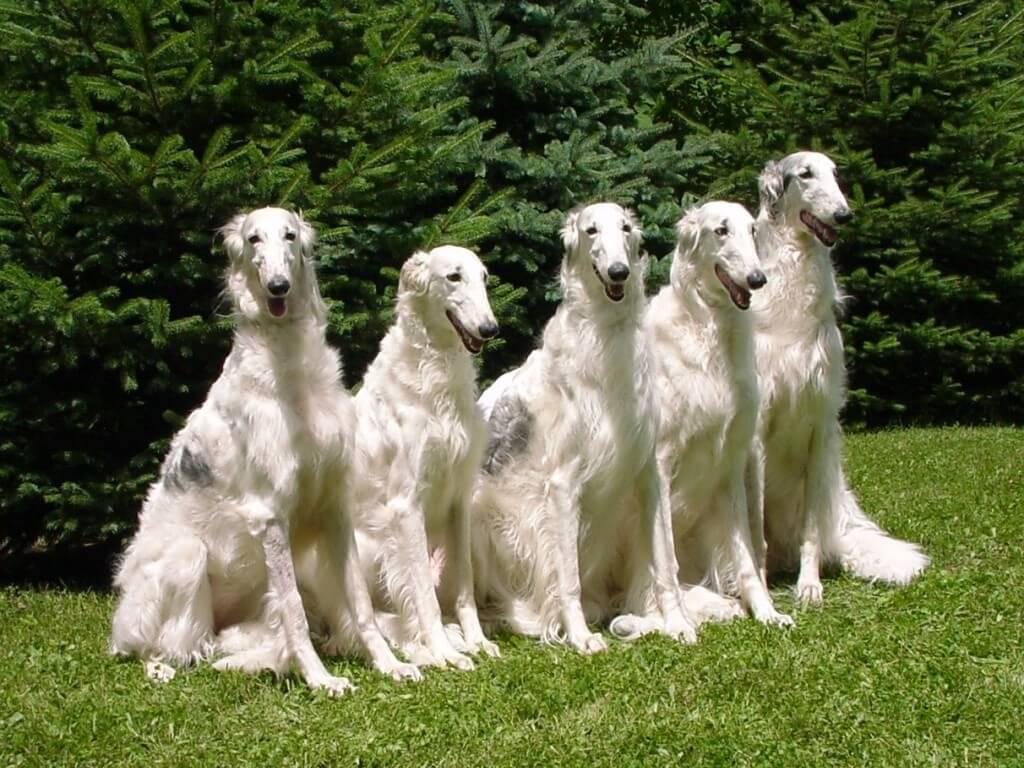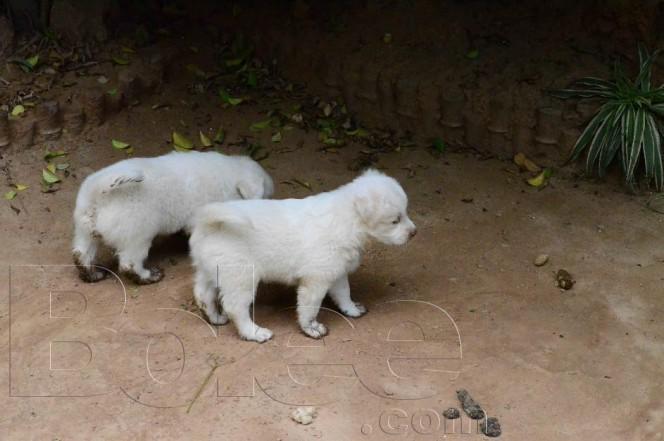The first image is the image on the left, the second image is the image on the right. Considering the images on both sides, is "Each image contains exactly one hound, and the hound on the right is white and stands with its body turned rightward, while the dog on the left has orange-and-white fur." valid? Answer yes or no. No. The first image is the image on the left, the second image is the image on the right. Analyze the images presented: Is the assertion "An image contains exactly two dogs." valid? Answer yes or no. Yes. 